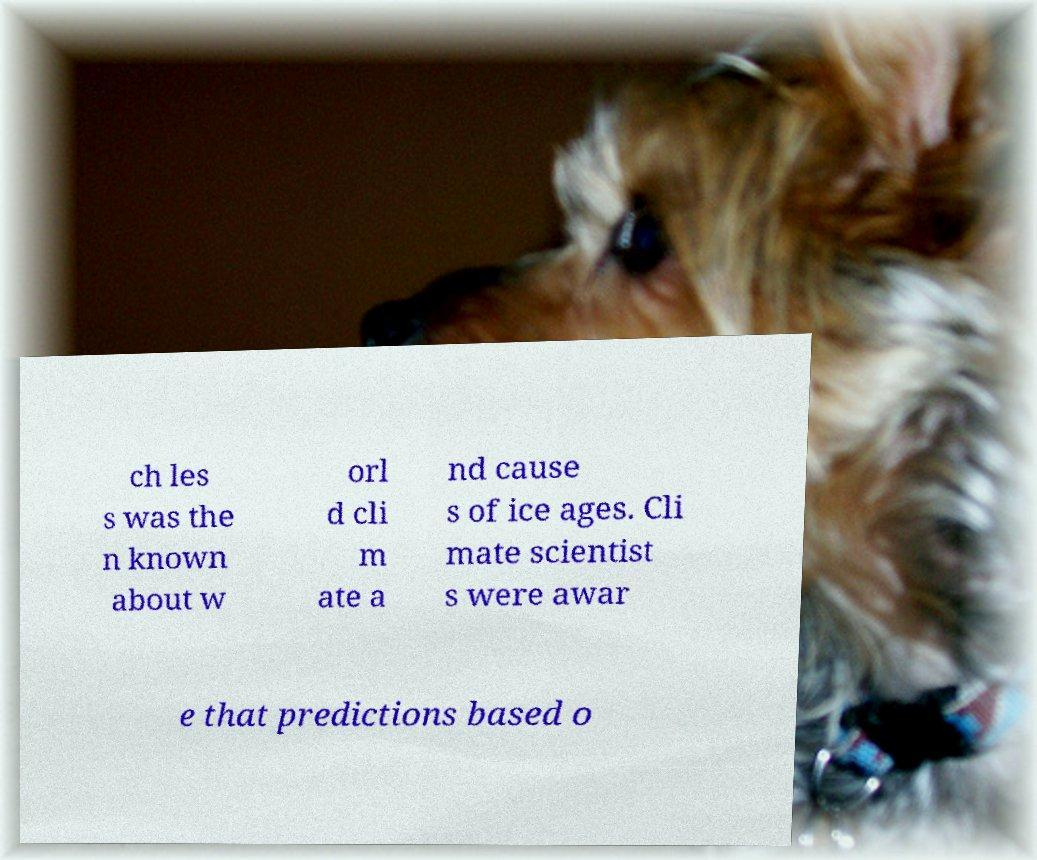Please read and relay the text visible in this image. What does it say? ch les s was the n known about w orl d cli m ate a nd cause s of ice ages. Cli mate scientist s were awar e that predictions based o 